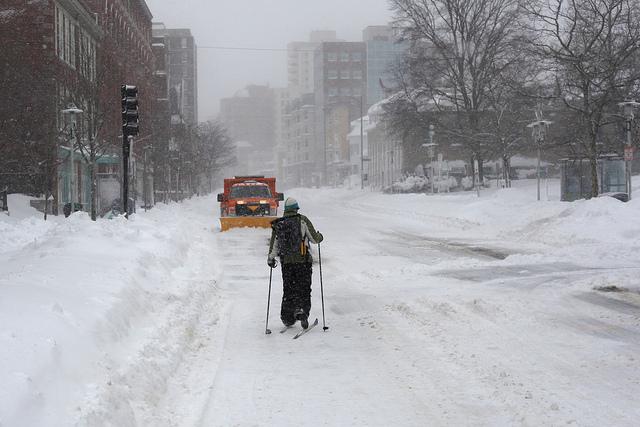Has the street been cleared?
Short answer required. Yes. Is it cold here?
Quick response, please. Yes. What type of equipment is shown in the picture?
Short answer required. Snow plow. 